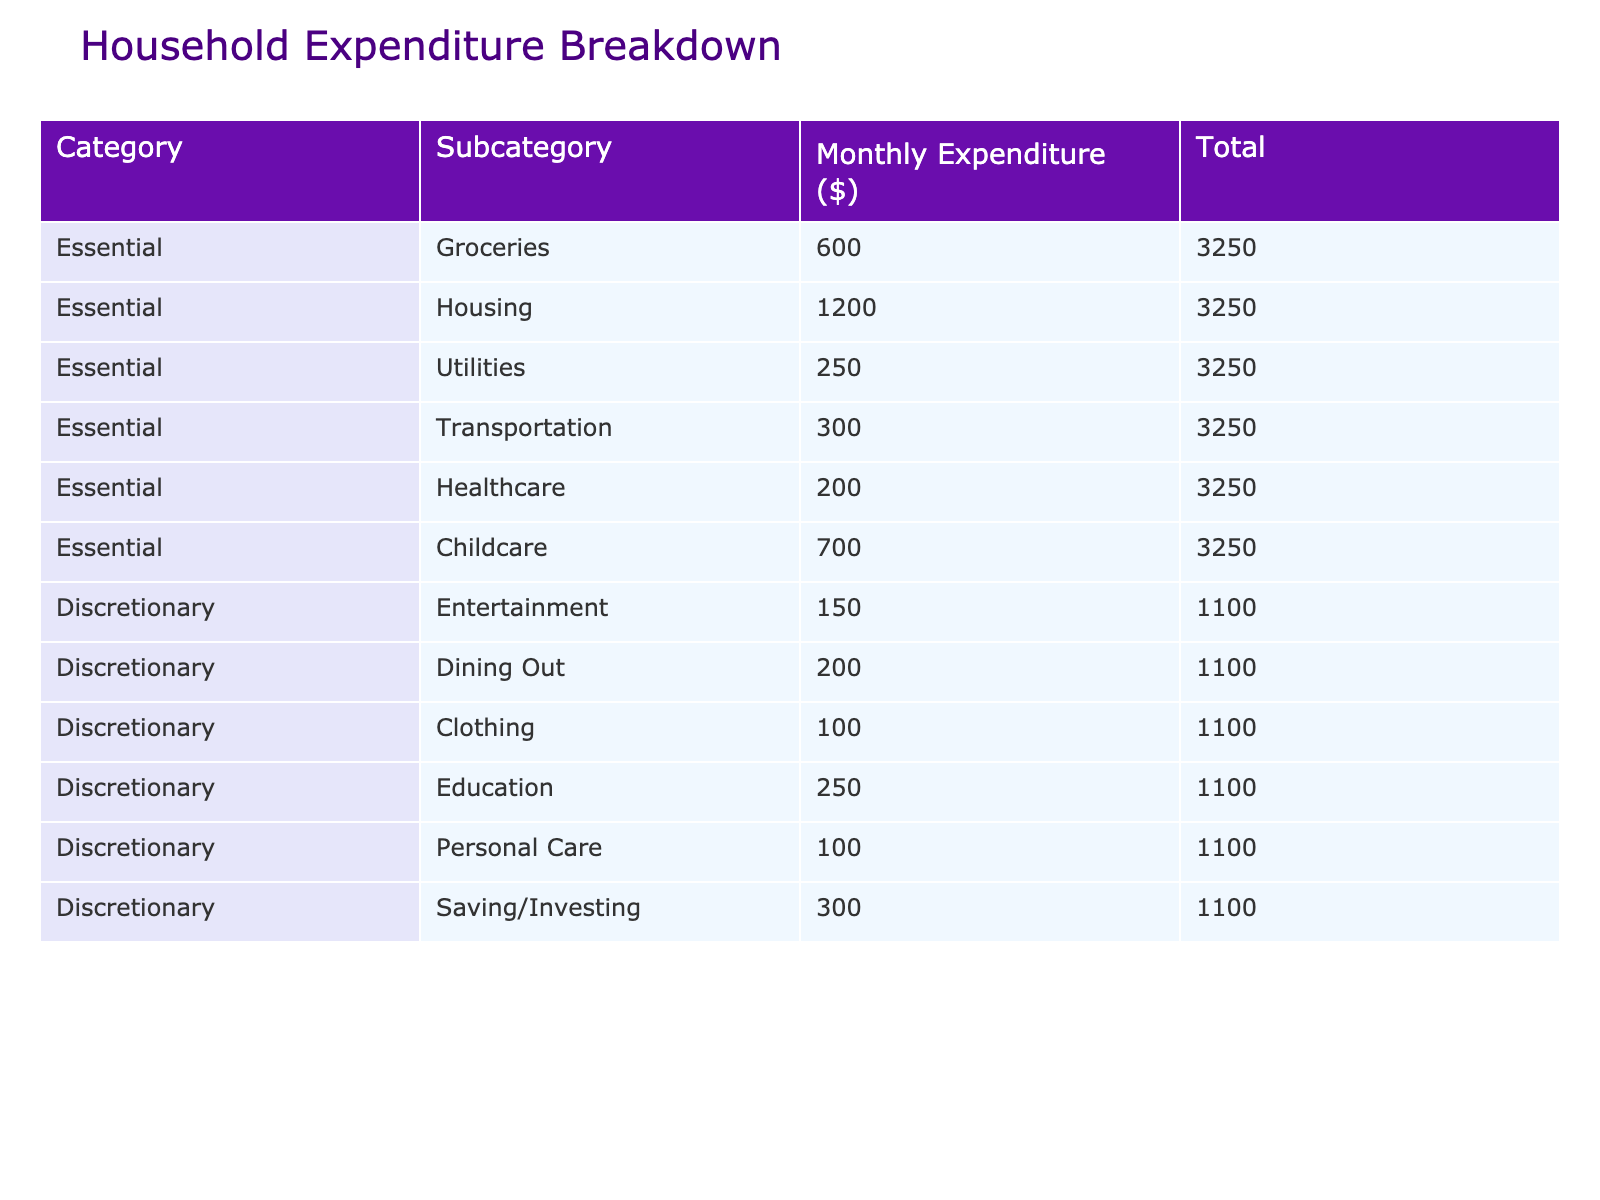What is the total monthly expenditure for essential needs? To find the total monthly expenditure for essential needs, we look at the 'Total' value for the essential category. Adding up the expenditures: 600 (Groceries) + 1200 (Housing) + 250 (Utilities) + 300 (Transportation) + 200 (Healthcare) + 700 (Childcare) = 3250.
Answer: 3250 How much do we spend on discretionary dining out? The table shows the expenditure on discretionary dining out as 200.
Answer: 200 What is the total monthly expenditure for discretionary spending? To find the total for discretionary spending, we add the expenditures for each subcategory: 150 (Entertainment) + 200 (Dining Out) + 100 (Clothing) + 250 (Education) + 100 (Personal Care) + 300 (Saving/Investing) = 1100.
Answer: 1100 Is the monthly expenditure on housing greater than for healthcare? The expenditure for housing is 1200, and for healthcare, it is 200. Since 1200 is greater than 200, the statement is true.
Answer: Yes What is the average spending on essential needs? To calculate the average spending on essential needs, we sum up the total (3250) and divide it by the number of essential subcategories (6): 3250 / 6 = 541.67.
Answer: 541.67 What is the difference in monthly expenditure between childcare and discretionary saving/investing? The expenditure on childcare is 700, and on saving/investing it is 300. The difference is 700 - 300 = 400.
Answer: 400 Is the combined spending on utilities and transportation less than the total expenditure on groceries and clothing? We first calculate the combined spending on utilities and transportation: 250 (Utilities) + 300 (Transportation) = 550. Next, we find the total for groceries and clothing: 600 (Groceries) + 100 (Clothing) = 700. Since 550 is less than 700, the statement is true.
Answer: Yes What is the total spending on healthcare and personal care compared to entertainment and education? First, we sum healthcare (200) and personal care (100) to get 300. Next, we sum entertainment (150) and education (250) to get 400. Comparing the two totals, 300 is less than 400.
Answer: 300 is less than 400 What percentage of total expenditure goes to childcare? The total expenditure for all categories is 3250 (essential) + 1100 (discretionary) = 4350. The expenditure on childcare is 700, so the percentage is (700 / 4350) * 100 = 16.09%.
Answer: 16.09% 